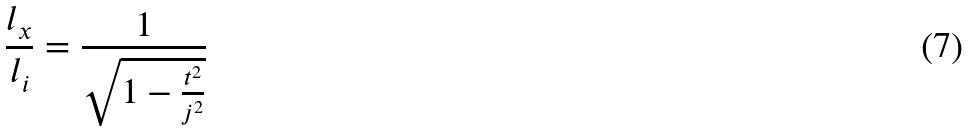Convert formula to latex. <formula><loc_0><loc_0><loc_500><loc_500>\frac { l _ { x } } { l _ { i } } = \frac { 1 } { \sqrt { 1 - \frac { t ^ { 2 } } { j ^ { 2 } } } }</formula> 